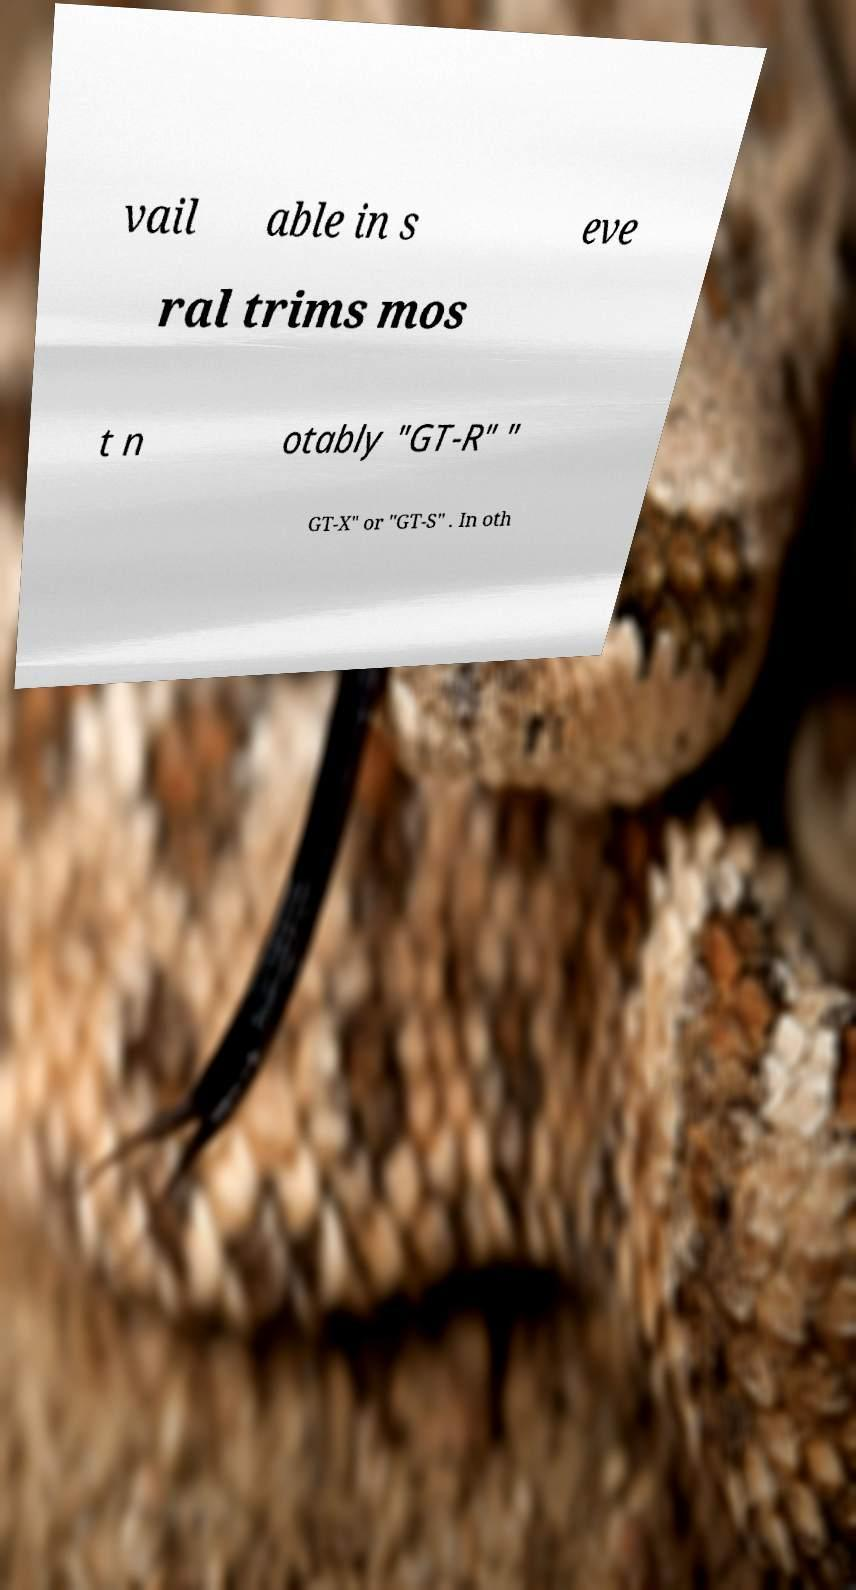Can you read and provide the text displayed in the image?This photo seems to have some interesting text. Can you extract and type it out for me? vail able in s eve ral trims mos t n otably "GT-R" " GT-X" or "GT-S" . In oth 